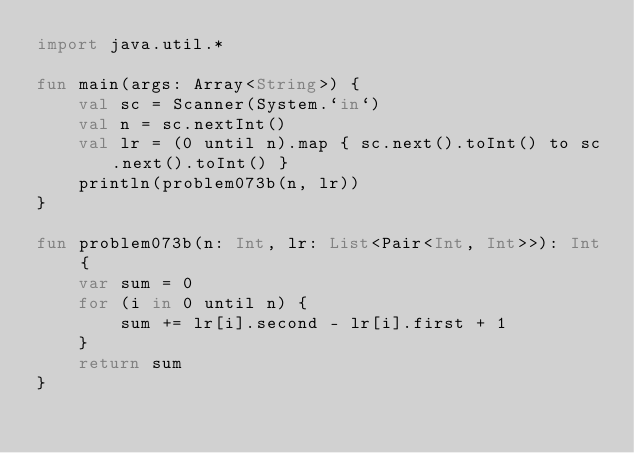<code> <loc_0><loc_0><loc_500><loc_500><_Kotlin_>import java.util.*

fun main(args: Array<String>) {
    val sc = Scanner(System.`in`)
    val n = sc.nextInt()
    val lr = (0 until n).map { sc.next().toInt() to sc.next().toInt() }
    println(problem073b(n, lr))
}

fun problem073b(n: Int, lr: List<Pair<Int, Int>>): Int {
    var sum = 0
    for (i in 0 until n) {
        sum += lr[i].second - lr[i].first + 1
    }
    return sum
}</code> 